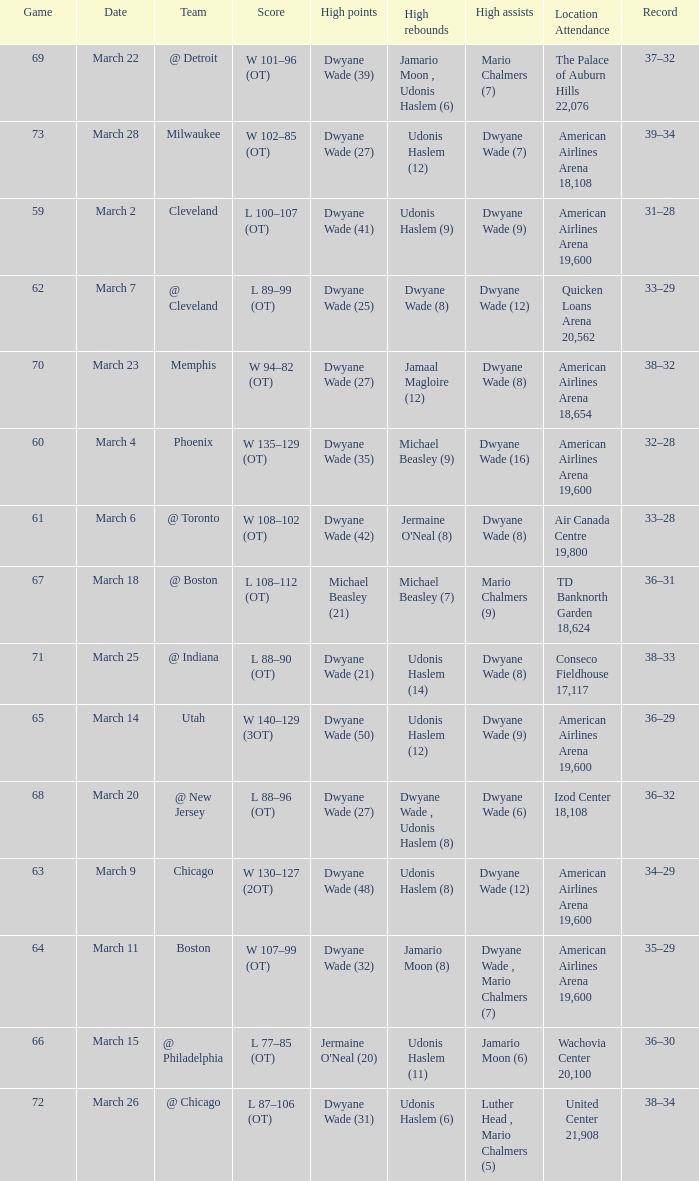Who had the high point total against cleveland? Dwyane Wade (41). 